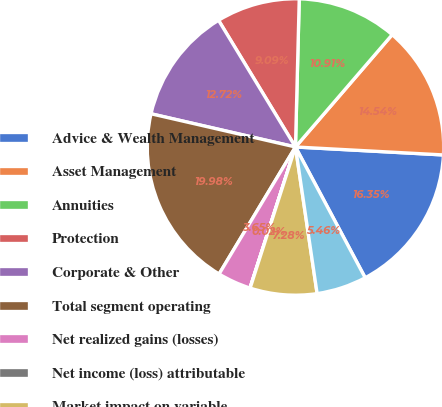Convert chart to OTSL. <chart><loc_0><loc_0><loc_500><loc_500><pie_chart><fcel>Advice & Wealth Management<fcel>Asset Management<fcel>Annuities<fcel>Protection<fcel>Corporate & Other<fcel>Total segment operating<fcel>Net realized gains (losses)<fcel>Net income (loss) attributable<fcel>Market impact on variable<fcel>Market impact on IUL benefits<nl><fcel>16.35%<fcel>14.54%<fcel>10.91%<fcel>9.09%<fcel>12.72%<fcel>19.98%<fcel>3.65%<fcel>0.02%<fcel>7.28%<fcel>5.46%<nl></chart> 